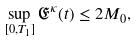<formula> <loc_0><loc_0><loc_500><loc_500>\sup _ { [ 0 , T _ { 1 } ] } \mathfrak { E } ^ { \kappa } ( t ) \leq 2 M _ { 0 } ,</formula> 